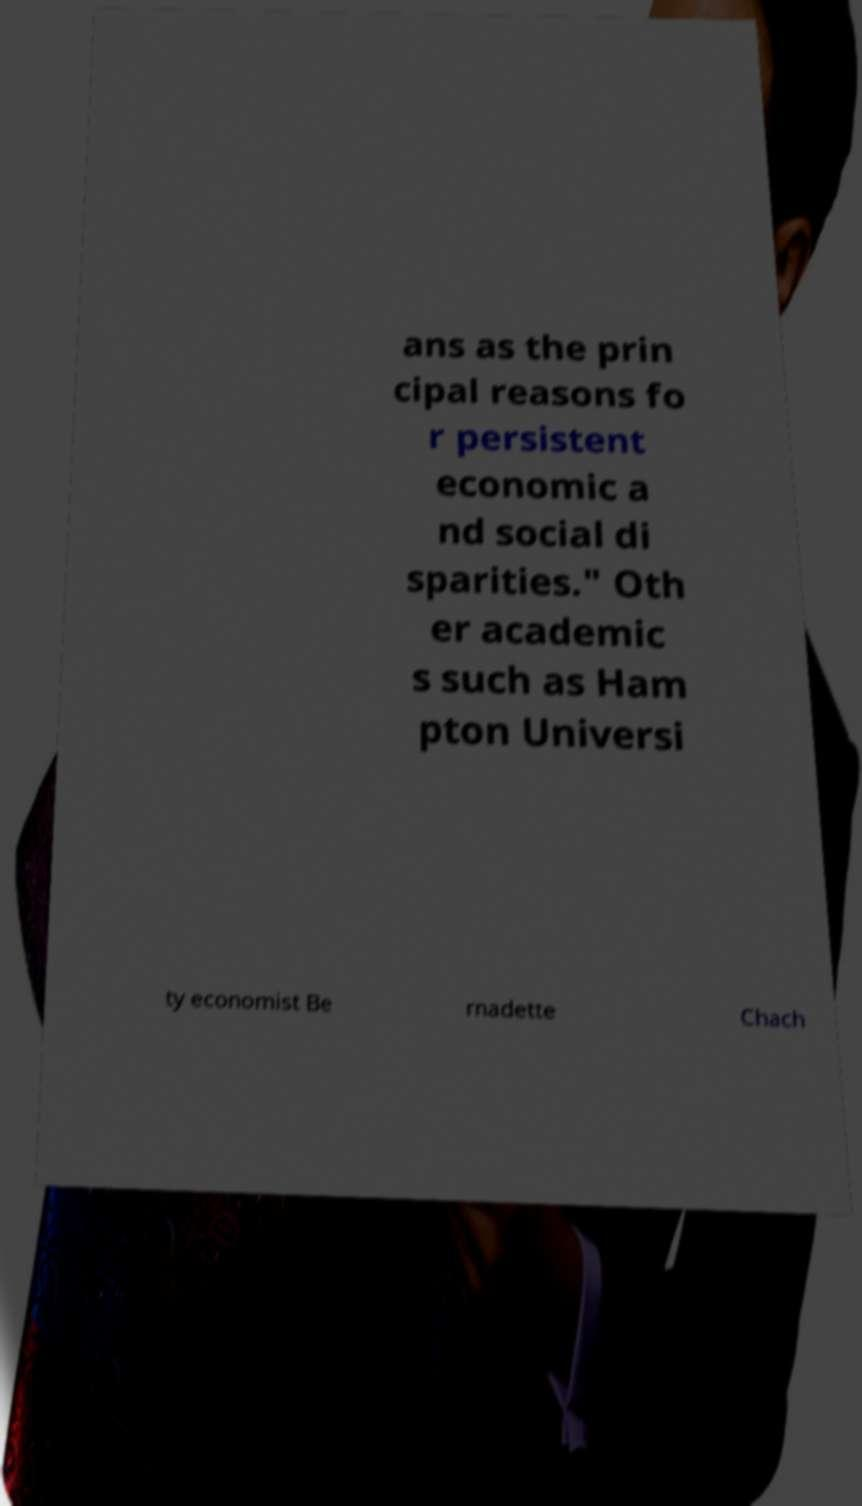What messages or text are displayed in this image? I need them in a readable, typed format. ans as the prin cipal reasons fo r persistent economic a nd social di sparities." Oth er academic s such as Ham pton Universi ty economist Be rnadette Chach 